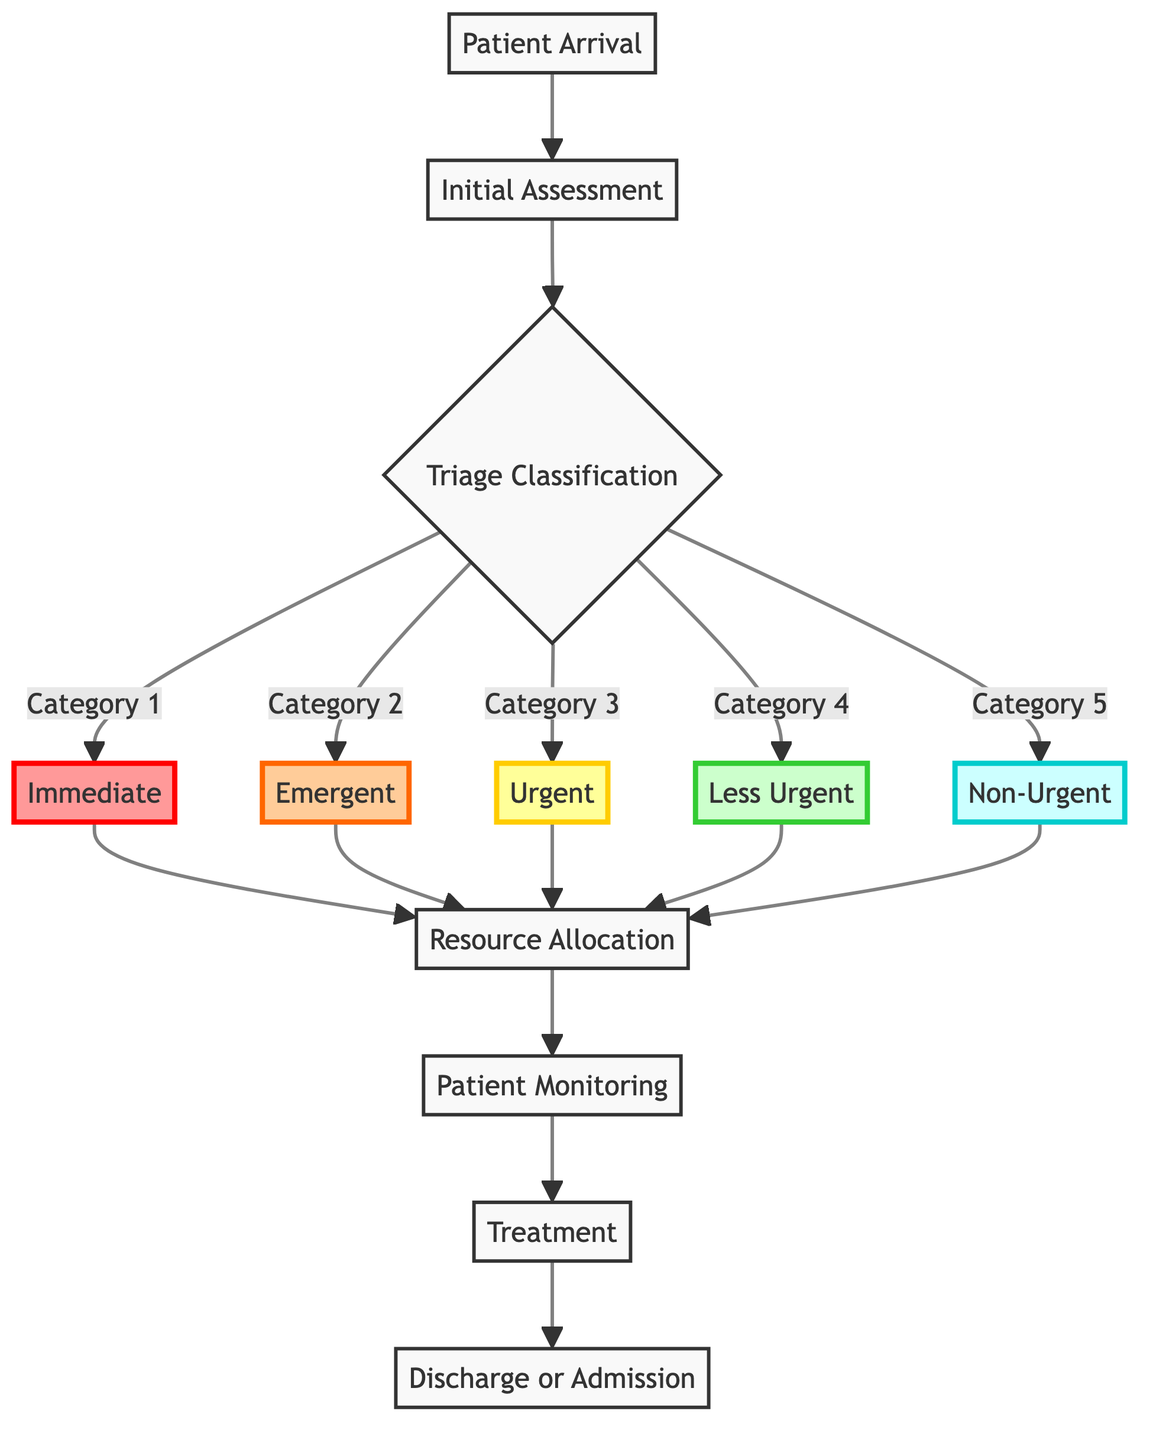What is the first step in the triage process? The first step identified in the diagram is "Patient Arrival," where patients come to the emergency room.
Answer: Patient Arrival How many triage categories are there? The diagram categorizes patients into five distinct categories based on urgency.
Answer: Five What does the "Initial Assessment" involve? The "Initial Assessment" is performed by the triage nurse, including checking vital signs, evaluating symptoms, and obtaining medical history.
Answer: Checking vital signs Which category requires immediate medical intervention? According to the diagram, "Category 1: Immediate" is for life-threatening conditions requiring immediate medical intervention.
Answer: Category 1: Immediate What step follows after triage classification? Once patients are classified into categories, the next step in the process is "Resource Allocation."
Answer: Resource Allocation If a patient falls under "Category 3: Urgent," which step proceeds afterward? A patient in "Category 3: Urgent" will move to "Resource Allocation" after triage classification to assign the necessary resources.
Answer: Resource Allocation What is the main goal of "Patient Monitoring"? "Patient Monitoring" focuses on continuous observation and re-evaluation of patients' conditions, especially those in higher priority categories.
Answer: Continuous observation What action is taken after treatment? After treatment, the next action is to decide whether patients are discharged or admitted for further treatment.
Answer: Discharge or Admission What is the shape of the relationship between "Patient Arrival" and "Initial Assessment"? The relationship between "Patient Arrival" and "Initial Assessment" is directional, indicating that patients must first arrive before being assessed.
Answer: Directional 